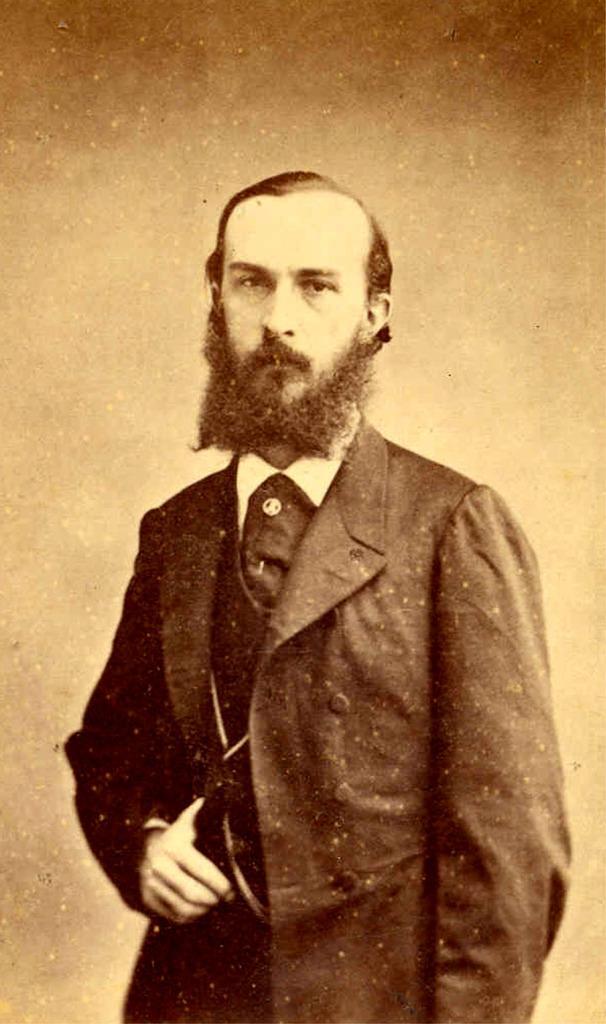Please provide a concise description of this image. In the foreground of this image, where a man in suit is standing and kept his thumb in between the shirt buttons. There is a cream and brown background. 